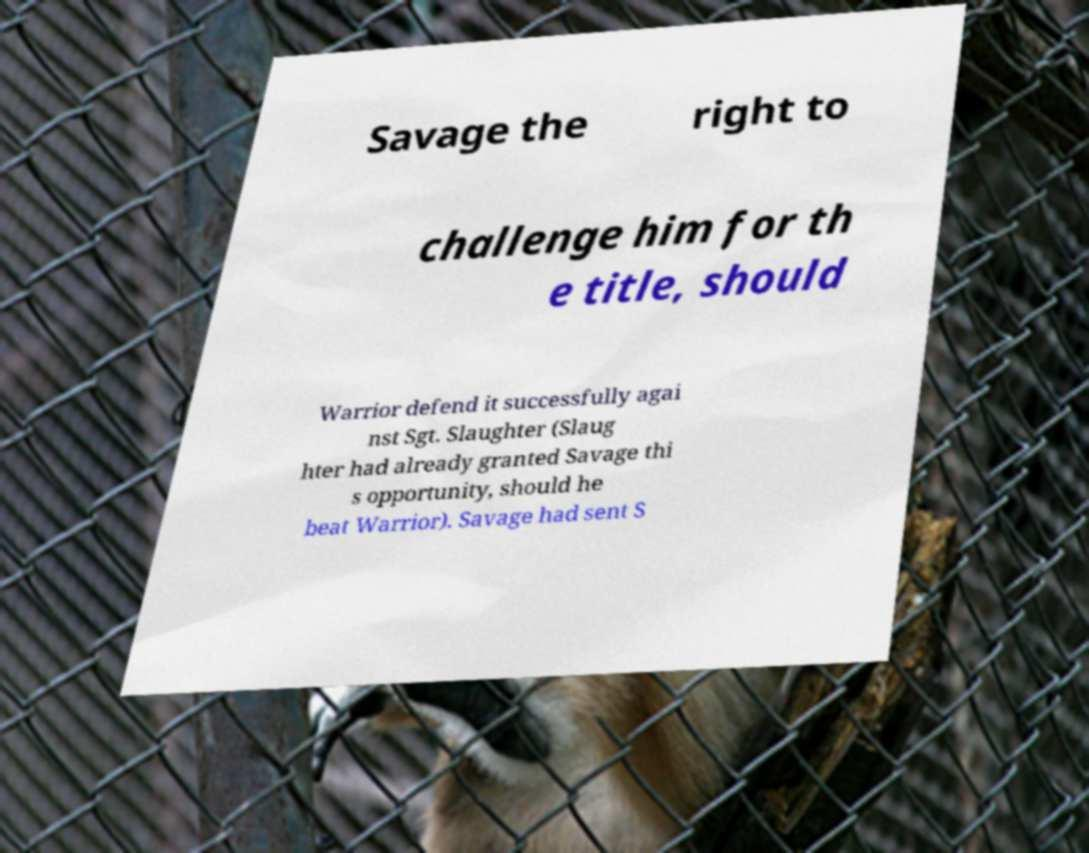Can you read and provide the text displayed in the image?This photo seems to have some interesting text. Can you extract and type it out for me? Savage the right to challenge him for th e title, should Warrior defend it successfully agai nst Sgt. Slaughter (Slaug hter had already granted Savage thi s opportunity, should he beat Warrior). Savage had sent S 